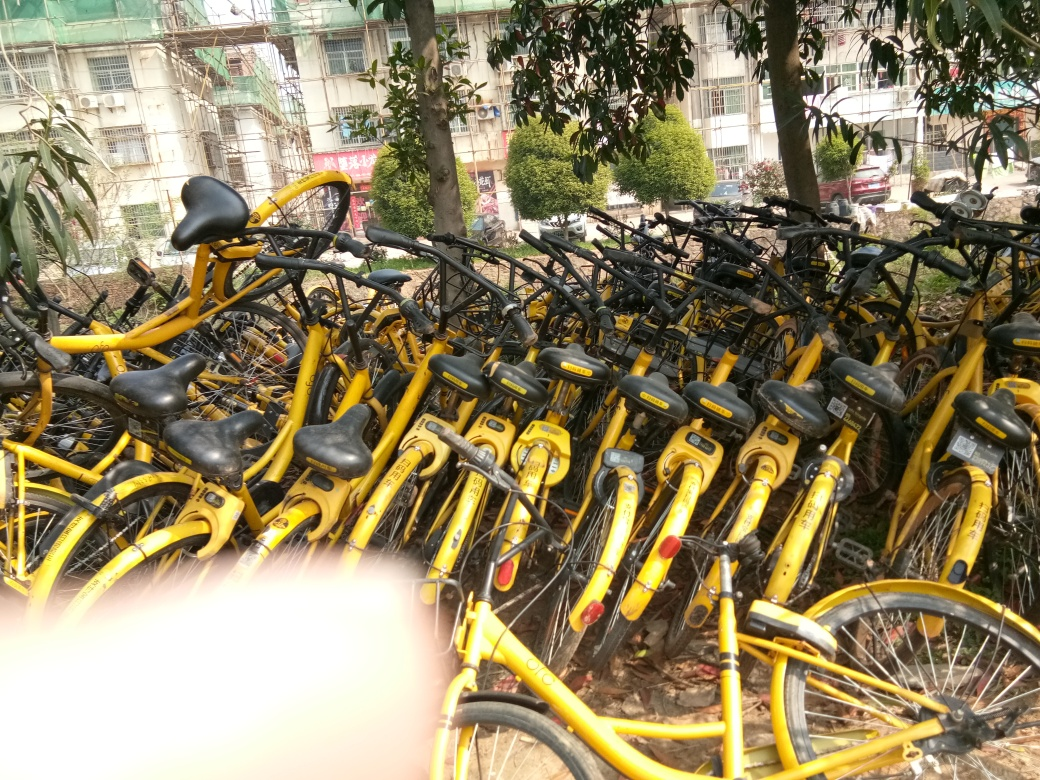Is the lighting sufficient? Yes, the lighting is sufficient to clearly see all the details of the yellow bicycles that are densely packed together. The natural light brightens up the space and allows one to observe the number of bicycles, their condition, and other elements in the background, like the surrounding foliage and building structure. 